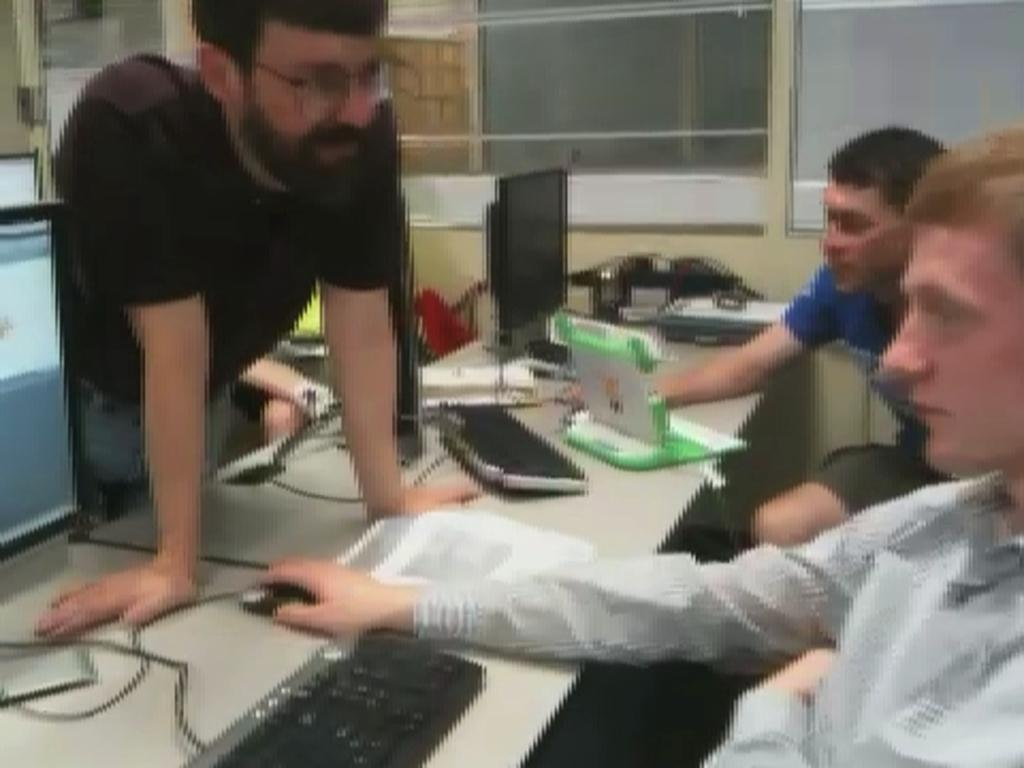How many people are in the image? There are persons in the image, but the exact number cannot be determined from the provided facts. What type of equipment is visible in the image? Monitors, keyboards, and mice are visible in the image. What is the primary piece of furniture in the image? There is a table in the image. What can be seen in the background of the image? There is a wall and a glass window in the background of the image, along with other objects. What type of marble is used for the floor in the image? There is no mention of a floor or marble in the provided facts, so it cannot be determined from the image. 